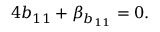<formula> <loc_0><loc_0><loc_500><loc_500>4 b _ { 1 1 } + \beta _ { b _ { 1 1 } } = 0 .</formula> 